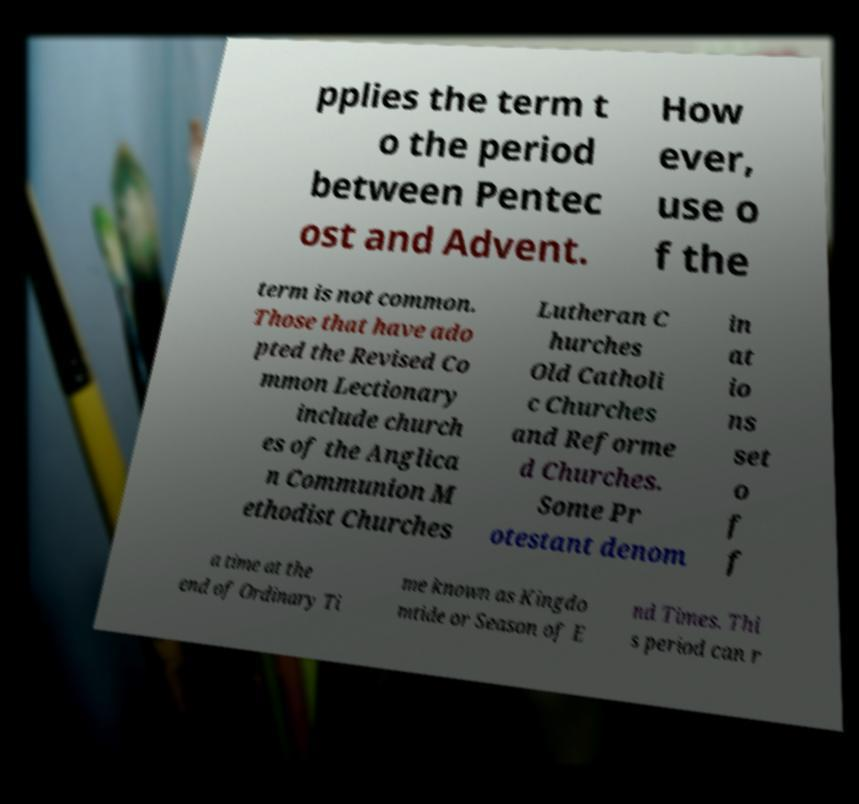Could you extract and type out the text from this image? pplies the term t o the period between Pentec ost and Advent. How ever, use o f the term is not common. Those that have ado pted the Revised Co mmon Lectionary include church es of the Anglica n Communion M ethodist Churches Lutheran C hurches Old Catholi c Churches and Reforme d Churches. Some Pr otestant denom in at io ns set o f f a time at the end of Ordinary Ti me known as Kingdo mtide or Season of E nd Times. Thi s period can r 